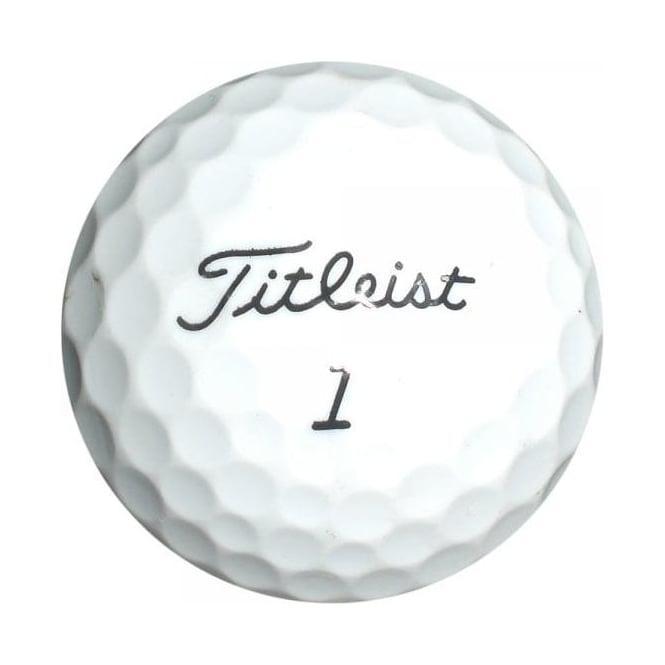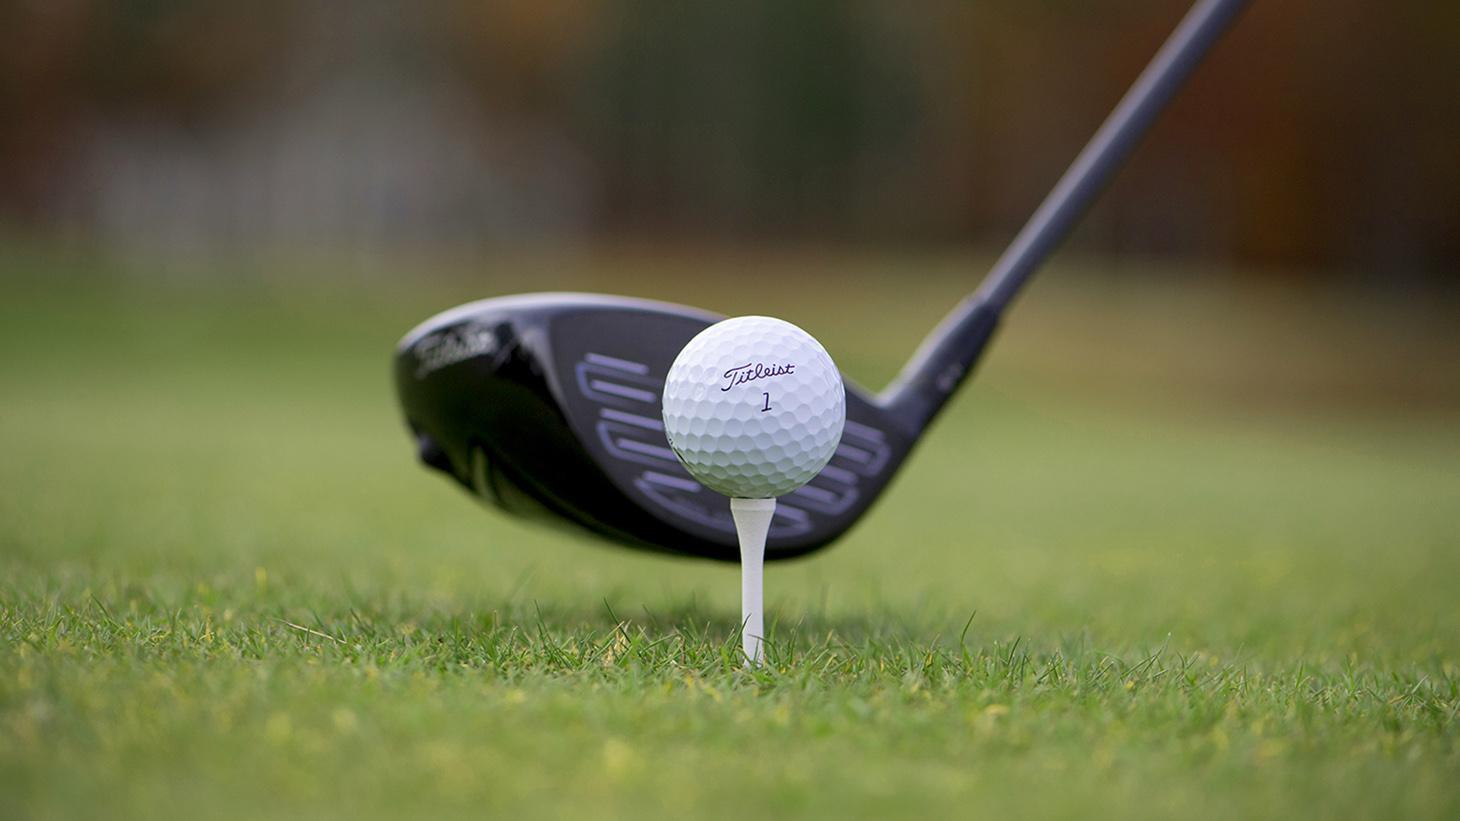The first image is the image on the left, the second image is the image on the right. Evaluate the accuracy of this statement regarding the images: "A golf ball is near a black golf club". Is it true? Answer yes or no. Yes. 